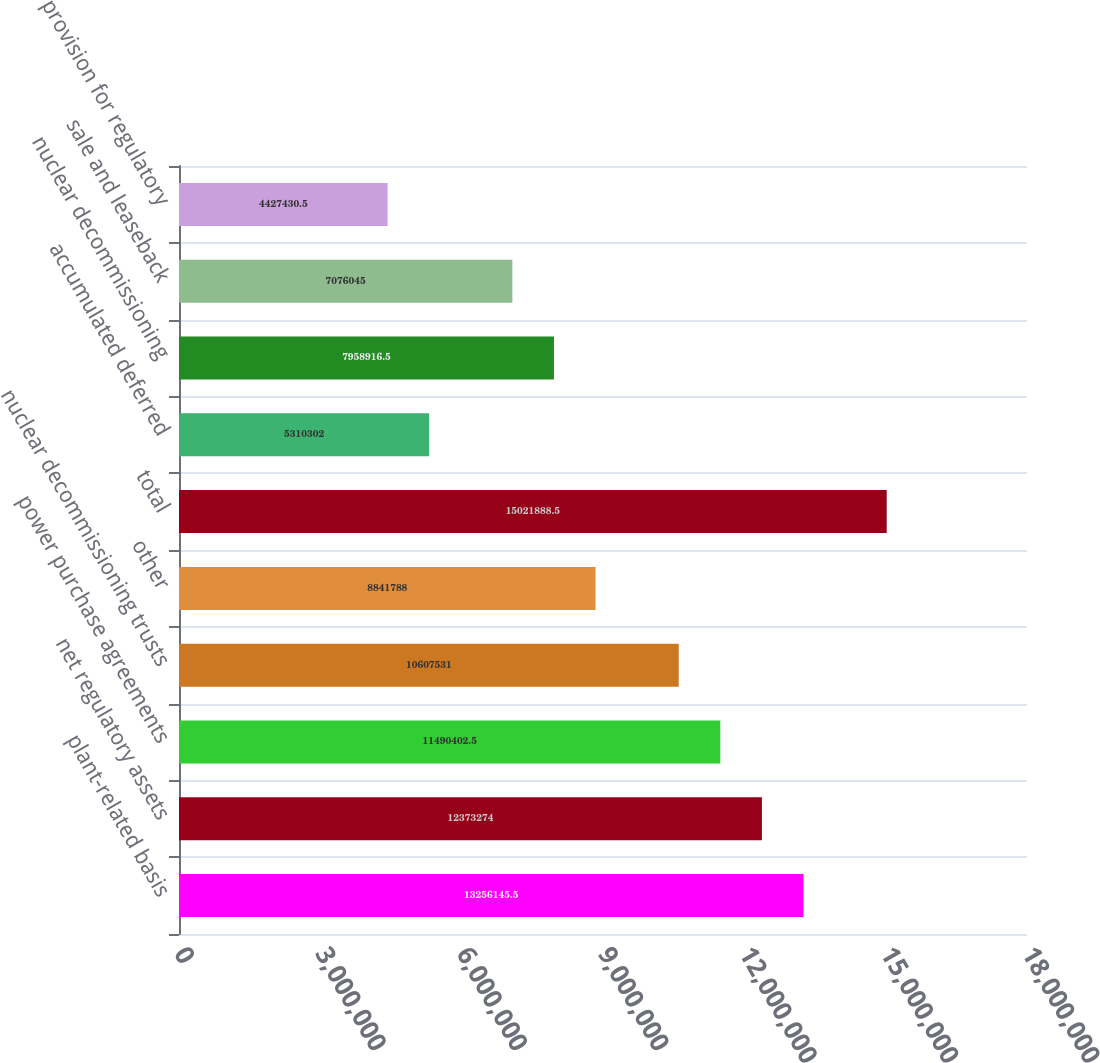<chart> <loc_0><loc_0><loc_500><loc_500><bar_chart><fcel>plant-related basis<fcel>net regulatory assets<fcel>power purchase agreements<fcel>nuclear decommissioning trusts<fcel>other<fcel>total<fcel>accumulated deferred<fcel>nuclear decommissioning<fcel>sale and leaseback<fcel>provision for regulatory<nl><fcel>1.32561e+07<fcel>1.23733e+07<fcel>1.14904e+07<fcel>1.06075e+07<fcel>8.84179e+06<fcel>1.50219e+07<fcel>5.3103e+06<fcel>7.95892e+06<fcel>7.07604e+06<fcel>4.42743e+06<nl></chart> 